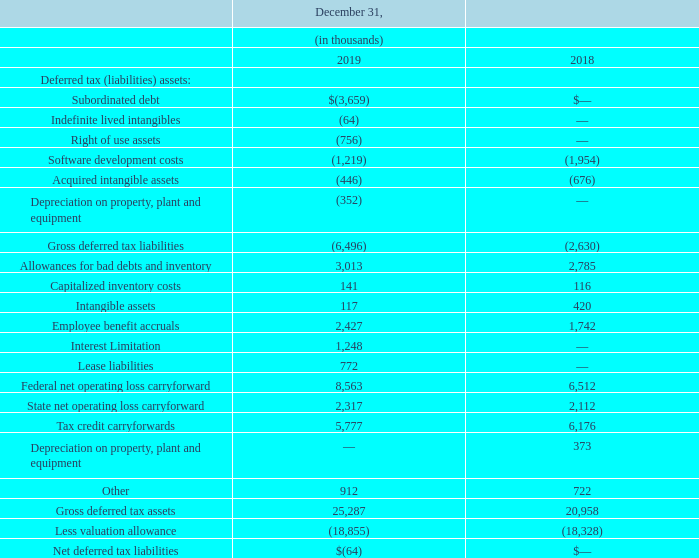Deferred tax (liabilities) assets are comprised of the following at:
The Company has Federal tax credit carryforwards of $5.4 million that expire in various tax years from 2028 to 2038. The Company has a Federal operating loss carryforward of $24.5 million expiring from 2029 through 2037 and a Federal operating loss carryforward of $17.9 million with an unlimited carryforward period. The Company also has state tax credit carryforwards of $0.3 million and state operating loss carryforwards of $43.3 million, which vary by jurisdiction and expire in various tax years through 2039.
In assessing the ability to realize deferred tax assets, management considers whether it is more likely than not that some portion or all of the deferred tax assets will not be realized. The ultimate realization of deferred tax assets is dependent upon the generation of future taxable income during the periods in which the temporary differences become deductible. Management considers the scheduled reversal of deferred tax liabilities, projected future taxable income, and tax planning strategies in making this assessment.
As a result of this analysis and based on the current year’s taxable income, and utilization of certain carryforwards management determined an increase in the valuation allowance in the current year to be appropriate.
In calculating the valuation allowance, the Company was not permitted to use its existing deferred tax liabilities related to its indefinite-lived intangible assets (i.e. “naked credit deferred tax liabilities”) as a source of taxable income to support the realization of its existing finite-lived deferred tax assets.
Due to the Tax Act, U.S. net operating losses ("NOLs") arising in tax years ending after December 31, 2017 will no longer be subject to the limited 20-year carryforward period. Under the new law, these NOLs carry forward indefinitely, resulting in the creation of indefinite-lived deferred tax assets. Consequently, as the Company schedules its deferred taxes and considers the ability to realize its deferred tax assets in future periods, it needs to consider how existing deferred tax assets, other than historical NOLs, will reverse.
If the reversal is expected to generate an indefinite carryforward NOL under the new law, this may impact the valuation allowance assessment. The indefinite carryforward period for NOLs also means that its deferred tax liabilities related to indefinite-lived intangibles, commonly referred to as “naked credits,” can be considered as support for realization. The adjustment for the 2019 “naked credit” resulted in a $0.01 million deferred tax liability.
In 2019, it was determined that the foreign tax credit carryforward of the Company would not be realizable. The reduction of the foreign tax credit carryforward resulted in a decrease in the valuation allowance for those credits. Therefore, there is no net income tax provision in 2019 related to the reduction in the foreign tax credit carryforward. A valuation allowance is required to the extent it is more likely than not that the future benefit associated with certain Federal and state tax loss carryforwards will not be realized.
The current year income tax provision includes a reduction of the Company’s valuation allowance due to the establishment of a deferred tax liability in connection with the issuance of convertible debt. The establishment of that deferred tax liability created “future taxable income” for the utilization of existing deferred tax assets of the Company, resulting in the $4 million reduction of the Company’s valuation allowance.
The Company records the benefits relating to uncertain tax positions only when it is more likely than not (likelihood of greater than 50%), based on technical merits, that the position would be sustained upon examination by taxing authorities. Tax positions that meet the more likely than not threshold are measured using a probability-weighted approach as the largest amount of tax benefit that is greater than 50% likely of being realized upon settlement.
At December 31, 2019, the Company’s reserve for uncertain tax positions is not material and we believe we have adequately provided for its tax-related liabilities. The Company is no longer subject to United States federal income tax examinations for years before 2014.
When will the Federal tax credit carryforwards of $5.4 million expire? Expire in various tax years from 2028 to 2038. When will the Federal tax credit carryforwards of $24.5 million expire? From 2029 through 2037. How much is the state tax credit carryforwards and  state operating loss carryforwards respectively? $0.3 million, $43.3 million. What is the change in Software development costs between December 31, 2018 and 2019?
Answer scale should be: thousand. 1,219-1,954
Answer: -735. What is the change in Acquired intangible assets between December 31, 2018 and 2019?
Answer scale should be: thousand. 446-676
Answer: -230. What is the average Software development costs for December 31, 2018 and 2019?
Answer scale should be: thousand. (1,219+1,954) / 2
Answer: 1586.5. 